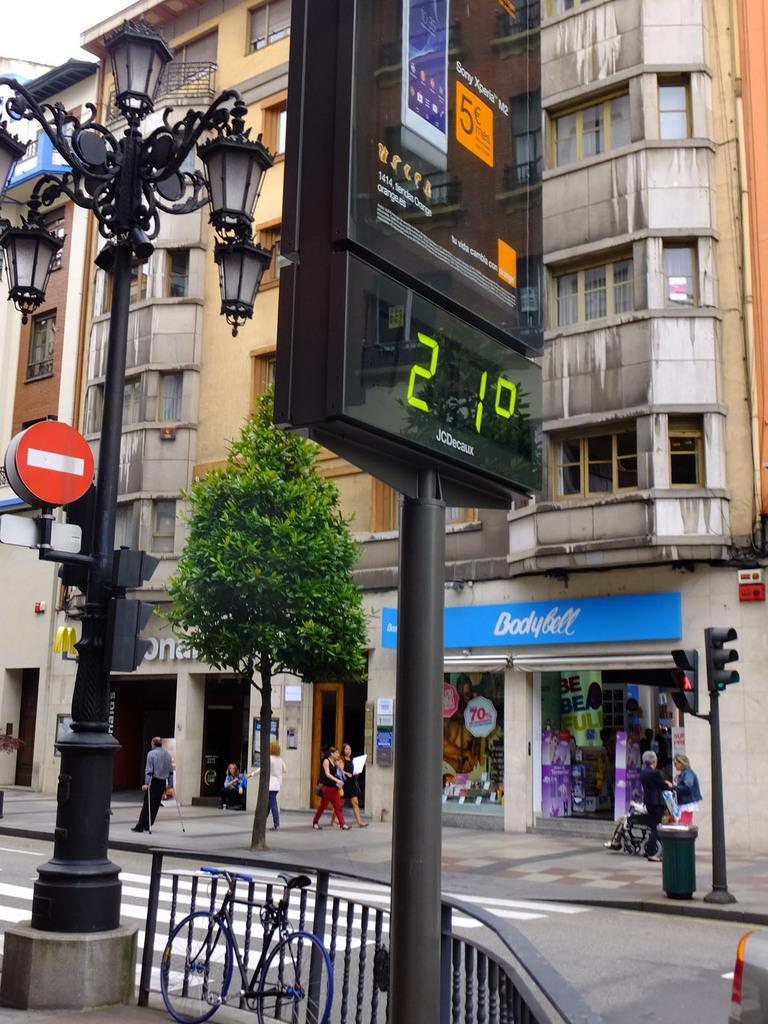Please provide a concise description of this image. In this image we can see buildings, street poles, street lights, display screens, grills, bicycle, bins, traffic poles, traffic signals, stores and persons walking on the road. 